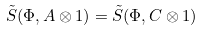<formula> <loc_0><loc_0><loc_500><loc_500>\tilde { S } ( \Phi , A \otimes 1 ) = \tilde { S } ( \Phi , C \otimes 1 )</formula> 